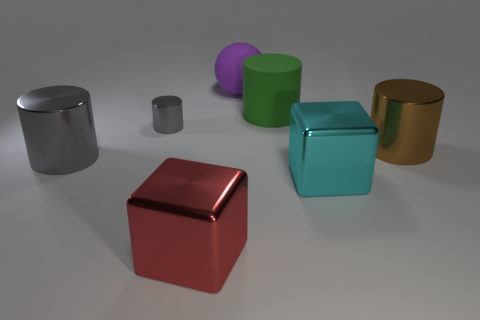Subtract all small cylinders. How many cylinders are left? 3 Add 1 large gray cylinders. How many objects exist? 8 Subtract all green cylinders. How many cylinders are left? 3 Subtract all blocks. How many objects are left? 5 Subtract 3 cylinders. How many cylinders are left? 1 Add 7 big green rubber objects. How many big green rubber objects are left? 8 Add 4 blue balls. How many blue balls exist? 4 Subtract 0 green blocks. How many objects are left? 7 Subtract all brown cylinders. Subtract all red blocks. How many cylinders are left? 3 Subtract all red balls. How many gray cylinders are left? 2 